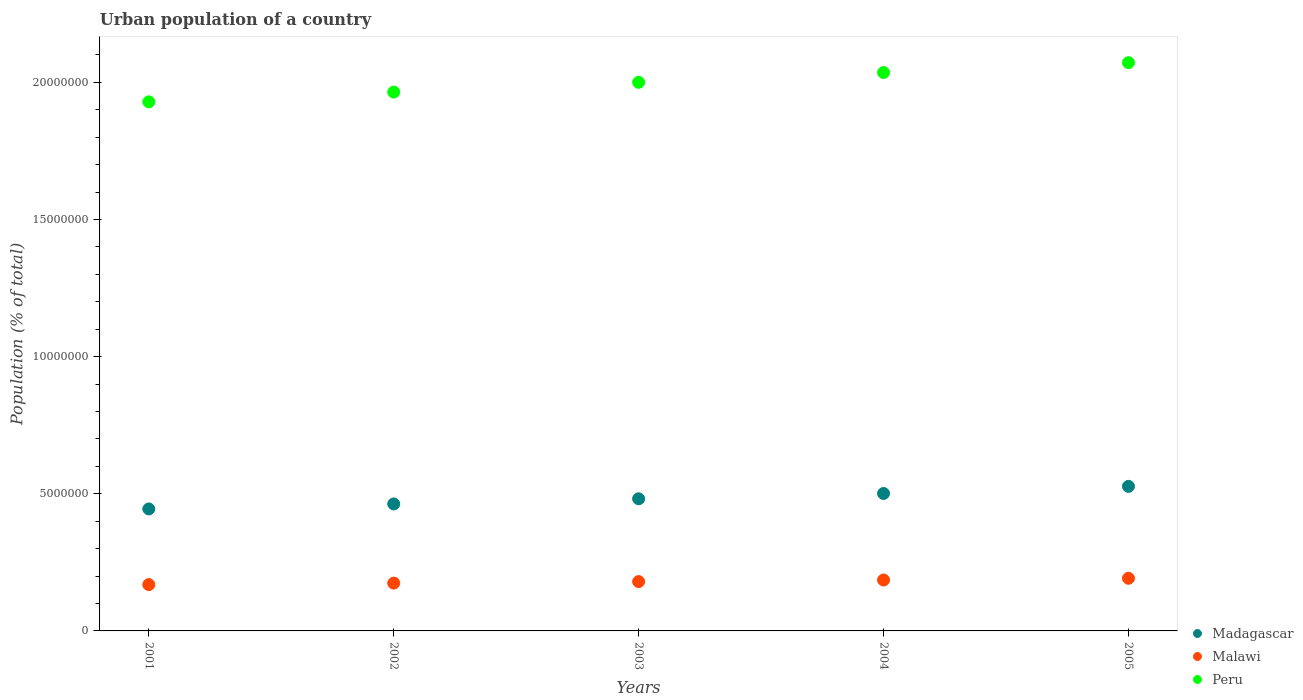How many different coloured dotlines are there?
Your answer should be very brief. 3. Is the number of dotlines equal to the number of legend labels?
Ensure brevity in your answer.  Yes. What is the urban population in Madagascar in 2001?
Your response must be concise. 4.45e+06. Across all years, what is the maximum urban population in Peru?
Ensure brevity in your answer.  2.07e+07. Across all years, what is the minimum urban population in Peru?
Offer a terse response. 1.93e+07. In which year was the urban population in Malawi minimum?
Your answer should be very brief. 2001. What is the total urban population in Peru in the graph?
Ensure brevity in your answer.  1.00e+08. What is the difference between the urban population in Madagascar in 2001 and that in 2002?
Your answer should be very brief. -1.83e+05. What is the difference between the urban population in Malawi in 2004 and the urban population in Madagascar in 2005?
Offer a very short reply. -3.41e+06. What is the average urban population in Peru per year?
Provide a succinct answer. 2.00e+07. In the year 2005, what is the difference between the urban population in Malawi and urban population in Peru?
Give a very brief answer. -1.88e+07. What is the ratio of the urban population in Madagascar in 2001 to that in 2005?
Ensure brevity in your answer.  0.84. Is the urban population in Madagascar in 2003 less than that in 2004?
Offer a terse response. Yes. Is the difference between the urban population in Malawi in 2001 and 2004 greater than the difference between the urban population in Peru in 2001 and 2004?
Give a very brief answer. Yes. What is the difference between the highest and the second highest urban population in Malawi?
Keep it short and to the point. 6.24e+04. What is the difference between the highest and the lowest urban population in Malawi?
Provide a short and direct response. 2.30e+05. Is the sum of the urban population in Madagascar in 2003 and 2004 greater than the maximum urban population in Peru across all years?
Your response must be concise. No. Is it the case that in every year, the sum of the urban population in Madagascar and urban population in Peru  is greater than the urban population in Malawi?
Make the answer very short. Yes. Does the urban population in Madagascar monotonically increase over the years?
Ensure brevity in your answer.  Yes. Is the urban population in Malawi strictly greater than the urban population in Peru over the years?
Your answer should be very brief. No. Is the urban population in Madagascar strictly less than the urban population in Malawi over the years?
Offer a very short reply. No. How many years are there in the graph?
Ensure brevity in your answer.  5. What is the difference between two consecutive major ticks on the Y-axis?
Provide a short and direct response. 5.00e+06. Does the graph contain any zero values?
Offer a terse response. No. Does the graph contain grids?
Offer a very short reply. No. What is the title of the graph?
Your answer should be compact. Urban population of a country. Does "Cabo Verde" appear as one of the legend labels in the graph?
Keep it short and to the point. No. What is the label or title of the Y-axis?
Your answer should be very brief. Population (% of total). What is the Population (% of total) of Madagascar in 2001?
Ensure brevity in your answer.  4.45e+06. What is the Population (% of total) of Malawi in 2001?
Give a very brief answer. 1.69e+06. What is the Population (% of total) in Peru in 2001?
Give a very brief answer. 1.93e+07. What is the Population (% of total) of Madagascar in 2002?
Your answer should be compact. 4.63e+06. What is the Population (% of total) in Malawi in 2002?
Provide a short and direct response. 1.74e+06. What is the Population (% of total) in Peru in 2002?
Your answer should be very brief. 1.96e+07. What is the Population (% of total) of Madagascar in 2003?
Keep it short and to the point. 4.82e+06. What is the Population (% of total) of Malawi in 2003?
Ensure brevity in your answer.  1.80e+06. What is the Population (% of total) in Peru in 2003?
Give a very brief answer. 2.00e+07. What is the Population (% of total) in Madagascar in 2004?
Make the answer very short. 5.01e+06. What is the Population (% of total) of Malawi in 2004?
Your answer should be compact. 1.86e+06. What is the Population (% of total) of Peru in 2004?
Give a very brief answer. 2.04e+07. What is the Population (% of total) in Madagascar in 2005?
Give a very brief answer. 5.27e+06. What is the Population (% of total) of Malawi in 2005?
Make the answer very short. 1.92e+06. What is the Population (% of total) in Peru in 2005?
Your answer should be very brief. 2.07e+07. Across all years, what is the maximum Population (% of total) in Madagascar?
Keep it short and to the point. 5.27e+06. Across all years, what is the maximum Population (% of total) of Malawi?
Provide a succinct answer. 1.92e+06. Across all years, what is the maximum Population (% of total) of Peru?
Your answer should be compact. 2.07e+07. Across all years, what is the minimum Population (% of total) of Madagascar?
Give a very brief answer. 4.45e+06. Across all years, what is the minimum Population (% of total) of Malawi?
Give a very brief answer. 1.69e+06. Across all years, what is the minimum Population (% of total) in Peru?
Offer a terse response. 1.93e+07. What is the total Population (% of total) in Madagascar in the graph?
Offer a very short reply. 2.42e+07. What is the total Population (% of total) in Malawi in the graph?
Make the answer very short. 9.01e+06. What is the total Population (% of total) of Peru in the graph?
Give a very brief answer. 1.00e+08. What is the difference between the Population (% of total) in Madagascar in 2001 and that in 2002?
Offer a very short reply. -1.83e+05. What is the difference between the Population (% of total) of Malawi in 2001 and that in 2002?
Make the answer very short. -5.40e+04. What is the difference between the Population (% of total) of Peru in 2001 and that in 2002?
Offer a very short reply. -3.57e+05. What is the difference between the Population (% of total) of Madagascar in 2001 and that in 2003?
Provide a short and direct response. -3.71e+05. What is the difference between the Population (% of total) of Malawi in 2001 and that in 2003?
Provide a short and direct response. -1.09e+05. What is the difference between the Population (% of total) of Peru in 2001 and that in 2003?
Offer a terse response. -7.13e+05. What is the difference between the Population (% of total) of Madagascar in 2001 and that in 2004?
Offer a terse response. -5.64e+05. What is the difference between the Population (% of total) in Malawi in 2001 and that in 2004?
Provide a short and direct response. -1.68e+05. What is the difference between the Population (% of total) in Peru in 2001 and that in 2004?
Give a very brief answer. -1.07e+06. What is the difference between the Population (% of total) in Madagascar in 2001 and that in 2005?
Offer a terse response. -8.23e+05. What is the difference between the Population (% of total) in Malawi in 2001 and that in 2005?
Your answer should be very brief. -2.30e+05. What is the difference between the Population (% of total) of Peru in 2001 and that in 2005?
Provide a succinct answer. -1.43e+06. What is the difference between the Population (% of total) in Madagascar in 2002 and that in 2003?
Your answer should be compact. -1.88e+05. What is the difference between the Population (% of total) of Malawi in 2002 and that in 2003?
Offer a terse response. -5.54e+04. What is the difference between the Population (% of total) in Peru in 2002 and that in 2003?
Offer a very short reply. -3.56e+05. What is the difference between the Population (% of total) in Madagascar in 2002 and that in 2004?
Offer a very short reply. -3.82e+05. What is the difference between the Population (% of total) of Malawi in 2002 and that in 2004?
Keep it short and to the point. -1.14e+05. What is the difference between the Population (% of total) in Peru in 2002 and that in 2004?
Keep it short and to the point. -7.13e+05. What is the difference between the Population (% of total) of Madagascar in 2002 and that in 2005?
Your answer should be very brief. -6.41e+05. What is the difference between the Population (% of total) in Malawi in 2002 and that in 2005?
Provide a short and direct response. -1.76e+05. What is the difference between the Population (% of total) in Peru in 2002 and that in 2005?
Your answer should be compact. -1.07e+06. What is the difference between the Population (% of total) of Madagascar in 2003 and that in 2004?
Offer a very short reply. -1.94e+05. What is the difference between the Population (% of total) in Malawi in 2003 and that in 2004?
Ensure brevity in your answer.  -5.82e+04. What is the difference between the Population (% of total) of Peru in 2003 and that in 2004?
Your answer should be compact. -3.57e+05. What is the difference between the Population (% of total) in Madagascar in 2003 and that in 2005?
Offer a terse response. -4.53e+05. What is the difference between the Population (% of total) in Malawi in 2003 and that in 2005?
Your response must be concise. -1.21e+05. What is the difference between the Population (% of total) of Peru in 2003 and that in 2005?
Your response must be concise. -7.16e+05. What is the difference between the Population (% of total) of Madagascar in 2004 and that in 2005?
Keep it short and to the point. -2.59e+05. What is the difference between the Population (% of total) of Malawi in 2004 and that in 2005?
Offer a terse response. -6.24e+04. What is the difference between the Population (% of total) of Peru in 2004 and that in 2005?
Provide a succinct answer. -3.59e+05. What is the difference between the Population (% of total) of Madagascar in 2001 and the Population (% of total) of Malawi in 2002?
Provide a short and direct response. 2.70e+06. What is the difference between the Population (% of total) in Madagascar in 2001 and the Population (% of total) in Peru in 2002?
Make the answer very short. -1.52e+07. What is the difference between the Population (% of total) of Malawi in 2001 and the Population (% of total) of Peru in 2002?
Provide a succinct answer. -1.80e+07. What is the difference between the Population (% of total) in Madagascar in 2001 and the Population (% of total) in Malawi in 2003?
Keep it short and to the point. 2.65e+06. What is the difference between the Population (% of total) of Madagascar in 2001 and the Population (% of total) of Peru in 2003?
Ensure brevity in your answer.  -1.56e+07. What is the difference between the Population (% of total) in Malawi in 2001 and the Population (% of total) in Peru in 2003?
Your answer should be compact. -1.83e+07. What is the difference between the Population (% of total) in Madagascar in 2001 and the Population (% of total) in Malawi in 2004?
Ensure brevity in your answer.  2.59e+06. What is the difference between the Population (% of total) of Madagascar in 2001 and the Population (% of total) of Peru in 2004?
Your answer should be very brief. -1.59e+07. What is the difference between the Population (% of total) of Malawi in 2001 and the Population (% of total) of Peru in 2004?
Offer a terse response. -1.87e+07. What is the difference between the Population (% of total) of Madagascar in 2001 and the Population (% of total) of Malawi in 2005?
Offer a very short reply. 2.53e+06. What is the difference between the Population (% of total) of Madagascar in 2001 and the Population (% of total) of Peru in 2005?
Provide a short and direct response. -1.63e+07. What is the difference between the Population (% of total) in Malawi in 2001 and the Population (% of total) in Peru in 2005?
Give a very brief answer. -1.90e+07. What is the difference between the Population (% of total) of Madagascar in 2002 and the Population (% of total) of Malawi in 2003?
Provide a succinct answer. 2.83e+06. What is the difference between the Population (% of total) in Madagascar in 2002 and the Population (% of total) in Peru in 2003?
Keep it short and to the point. -1.54e+07. What is the difference between the Population (% of total) in Malawi in 2002 and the Population (% of total) in Peru in 2003?
Ensure brevity in your answer.  -1.83e+07. What is the difference between the Population (% of total) of Madagascar in 2002 and the Population (% of total) of Malawi in 2004?
Give a very brief answer. 2.77e+06. What is the difference between the Population (% of total) of Madagascar in 2002 and the Population (% of total) of Peru in 2004?
Provide a short and direct response. -1.57e+07. What is the difference between the Population (% of total) in Malawi in 2002 and the Population (% of total) in Peru in 2004?
Give a very brief answer. -1.86e+07. What is the difference between the Population (% of total) in Madagascar in 2002 and the Population (% of total) in Malawi in 2005?
Keep it short and to the point. 2.71e+06. What is the difference between the Population (% of total) of Madagascar in 2002 and the Population (% of total) of Peru in 2005?
Provide a succinct answer. -1.61e+07. What is the difference between the Population (% of total) of Malawi in 2002 and the Population (% of total) of Peru in 2005?
Offer a very short reply. -1.90e+07. What is the difference between the Population (% of total) of Madagascar in 2003 and the Population (% of total) of Malawi in 2004?
Ensure brevity in your answer.  2.96e+06. What is the difference between the Population (% of total) of Madagascar in 2003 and the Population (% of total) of Peru in 2004?
Provide a short and direct response. -1.55e+07. What is the difference between the Population (% of total) of Malawi in 2003 and the Population (% of total) of Peru in 2004?
Your response must be concise. -1.86e+07. What is the difference between the Population (% of total) in Madagascar in 2003 and the Population (% of total) in Malawi in 2005?
Keep it short and to the point. 2.90e+06. What is the difference between the Population (% of total) in Madagascar in 2003 and the Population (% of total) in Peru in 2005?
Provide a succinct answer. -1.59e+07. What is the difference between the Population (% of total) of Malawi in 2003 and the Population (% of total) of Peru in 2005?
Provide a succinct answer. -1.89e+07. What is the difference between the Population (% of total) of Madagascar in 2004 and the Population (% of total) of Malawi in 2005?
Keep it short and to the point. 3.09e+06. What is the difference between the Population (% of total) of Madagascar in 2004 and the Population (% of total) of Peru in 2005?
Make the answer very short. -1.57e+07. What is the difference between the Population (% of total) of Malawi in 2004 and the Population (% of total) of Peru in 2005?
Provide a succinct answer. -1.89e+07. What is the average Population (% of total) in Madagascar per year?
Give a very brief answer. 4.84e+06. What is the average Population (% of total) in Malawi per year?
Your answer should be very brief. 1.80e+06. What is the average Population (% of total) of Peru per year?
Your response must be concise. 2.00e+07. In the year 2001, what is the difference between the Population (% of total) of Madagascar and Population (% of total) of Malawi?
Ensure brevity in your answer.  2.76e+06. In the year 2001, what is the difference between the Population (% of total) in Madagascar and Population (% of total) in Peru?
Provide a short and direct response. -1.48e+07. In the year 2001, what is the difference between the Population (% of total) of Malawi and Population (% of total) of Peru?
Give a very brief answer. -1.76e+07. In the year 2002, what is the difference between the Population (% of total) of Madagascar and Population (% of total) of Malawi?
Your answer should be very brief. 2.89e+06. In the year 2002, what is the difference between the Population (% of total) in Madagascar and Population (% of total) in Peru?
Give a very brief answer. -1.50e+07. In the year 2002, what is the difference between the Population (% of total) in Malawi and Population (% of total) in Peru?
Ensure brevity in your answer.  -1.79e+07. In the year 2003, what is the difference between the Population (% of total) of Madagascar and Population (% of total) of Malawi?
Your answer should be compact. 3.02e+06. In the year 2003, what is the difference between the Population (% of total) of Madagascar and Population (% of total) of Peru?
Give a very brief answer. -1.52e+07. In the year 2003, what is the difference between the Population (% of total) in Malawi and Population (% of total) in Peru?
Make the answer very short. -1.82e+07. In the year 2004, what is the difference between the Population (% of total) of Madagascar and Population (% of total) of Malawi?
Your answer should be compact. 3.15e+06. In the year 2004, what is the difference between the Population (% of total) of Madagascar and Population (% of total) of Peru?
Give a very brief answer. -1.53e+07. In the year 2004, what is the difference between the Population (% of total) of Malawi and Population (% of total) of Peru?
Your answer should be compact. -1.85e+07. In the year 2005, what is the difference between the Population (% of total) in Madagascar and Population (% of total) in Malawi?
Your response must be concise. 3.35e+06. In the year 2005, what is the difference between the Population (% of total) of Madagascar and Population (% of total) of Peru?
Keep it short and to the point. -1.54e+07. In the year 2005, what is the difference between the Population (% of total) in Malawi and Population (% of total) in Peru?
Keep it short and to the point. -1.88e+07. What is the ratio of the Population (% of total) of Madagascar in 2001 to that in 2002?
Keep it short and to the point. 0.96. What is the ratio of the Population (% of total) of Malawi in 2001 to that in 2002?
Provide a short and direct response. 0.97. What is the ratio of the Population (% of total) in Peru in 2001 to that in 2002?
Give a very brief answer. 0.98. What is the ratio of the Population (% of total) in Madagascar in 2001 to that in 2003?
Your response must be concise. 0.92. What is the ratio of the Population (% of total) of Malawi in 2001 to that in 2003?
Offer a very short reply. 0.94. What is the ratio of the Population (% of total) in Peru in 2001 to that in 2003?
Offer a terse response. 0.96. What is the ratio of the Population (% of total) of Madagascar in 2001 to that in 2004?
Offer a terse response. 0.89. What is the ratio of the Population (% of total) of Malawi in 2001 to that in 2004?
Make the answer very short. 0.91. What is the ratio of the Population (% of total) of Peru in 2001 to that in 2004?
Your answer should be very brief. 0.95. What is the ratio of the Population (% of total) of Madagascar in 2001 to that in 2005?
Your response must be concise. 0.84. What is the ratio of the Population (% of total) in Malawi in 2001 to that in 2005?
Your answer should be very brief. 0.88. What is the ratio of the Population (% of total) in Peru in 2001 to that in 2005?
Your answer should be very brief. 0.93. What is the ratio of the Population (% of total) in Malawi in 2002 to that in 2003?
Your answer should be very brief. 0.97. What is the ratio of the Population (% of total) in Peru in 2002 to that in 2003?
Provide a short and direct response. 0.98. What is the ratio of the Population (% of total) of Madagascar in 2002 to that in 2004?
Give a very brief answer. 0.92. What is the ratio of the Population (% of total) in Malawi in 2002 to that in 2004?
Provide a succinct answer. 0.94. What is the ratio of the Population (% of total) of Peru in 2002 to that in 2004?
Keep it short and to the point. 0.96. What is the ratio of the Population (% of total) of Madagascar in 2002 to that in 2005?
Provide a short and direct response. 0.88. What is the ratio of the Population (% of total) in Malawi in 2002 to that in 2005?
Your response must be concise. 0.91. What is the ratio of the Population (% of total) in Peru in 2002 to that in 2005?
Give a very brief answer. 0.95. What is the ratio of the Population (% of total) of Madagascar in 2003 to that in 2004?
Keep it short and to the point. 0.96. What is the ratio of the Population (% of total) in Malawi in 2003 to that in 2004?
Offer a terse response. 0.97. What is the ratio of the Population (% of total) in Peru in 2003 to that in 2004?
Your response must be concise. 0.98. What is the ratio of the Population (% of total) in Madagascar in 2003 to that in 2005?
Offer a very short reply. 0.91. What is the ratio of the Population (% of total) of Malawi in 2003 to that in 2005?
Your response must be concise. 0.94. What is the ratio of the Population (% of total) in Peru in 2003 to that in 2005?
Your answer should be very brief. 0.97. What is the ratio of the Population (% of total) in Madagascar in 2004 to that in 2005?
Keep it short and to the point. 0.95. What is the ratio of the Population (% of total) of Malawi in 2004 to that in 2005?
Give a very brief answer. 0.97. What is the ratio of the Population (% of total) in Peru in 2004 to that in 2005?
Ensure brevity in your answer.  0.98. What is the difference between the highest and the second highest Population (% of total) of Madagascar?
Make the answer very short. 2.59e+05. What is the difference between the highest and the second highest Population (% of total) of Malawi?
Offer a terse response. 6.24e+04. What is the difference between the highest and the second highest Population (% of total) of Peru?
Offer a very short reply. 3.59e+05. What is the difference between the highest and the lowest Population (% of total) of Madagascar?
Your answer should be compact. 8.23e+05. What is the difference between the highest and the lowest Population (% of total) of Malawi?
Provide a short and direct response. 2.30e+05. What is the difference between the highest and the lowest Population (% of total) of Peru?
Your answer should be very brief. 1.43e+06. 